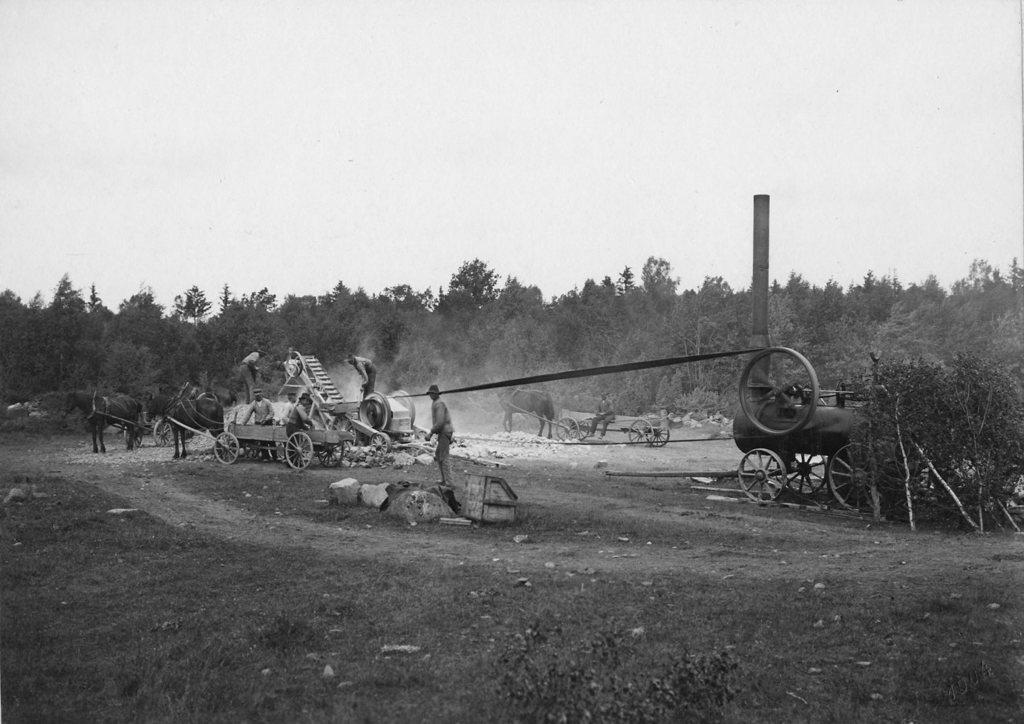What type of objects can be seen in the image? There are carts, animals, people, trees, and other objects in the image. What is the location of the animals in the image? The animals are on the ground in the image. Can you describe the people in the image? There are people present in the image, but their specific actions or characteristics are not mentioned in the provided facts. What type of vegetation is visible in the image? There are trees in the image. What is visible in the background of the image? The sky is visible in the background of the image. Where is the wren perched in the image? There is no wren present in the image. What type of wilderness can be seen in the image? The image does not depict a wilderness setting; it contains carts, animals, people, trees, and other objects. Can you tell me how many faucets are visible in the image? There are no faucets present in the image. 